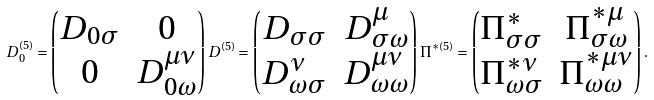Convert formula to latex. <formula><loc_0><loc_0><loc_500><loc_500>D _ { 0 } ^ { ( 5 ) } = \begin{pmatrix} D _ { 0 \sigma } & 0 \\ 0 & D ^ { \mu \nu } _ { 0 \omega } \end{pmatrix} D ^ { ( 5 ) } = \begin{pmatrix} D _ { \sigma \sigma } & D _ { \sigma \omega } ^ { \mu } \\ D _ { \omega \sigma } ^ { \nu } & D ^ { \mu \nu } _ { \omega \omega } \end{pmatrix} \Pi ^ { * ( 5 ) } = \begin{pmatrix} \Pi _ { \sigma \sigma } ^ { * } & \Pi ^ { * \mu } _ { \sigma \omega } \\ \Pi ^ { * \nu } _ { \omega \sigma } & \Pi ^ { * \mu \nu } _ { \omega \omega } \end{pmatrix} .</formula> 